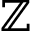<formula> <loc_0><loc_0><loc_500><loc_500>\mathbb { Z }</formula> 